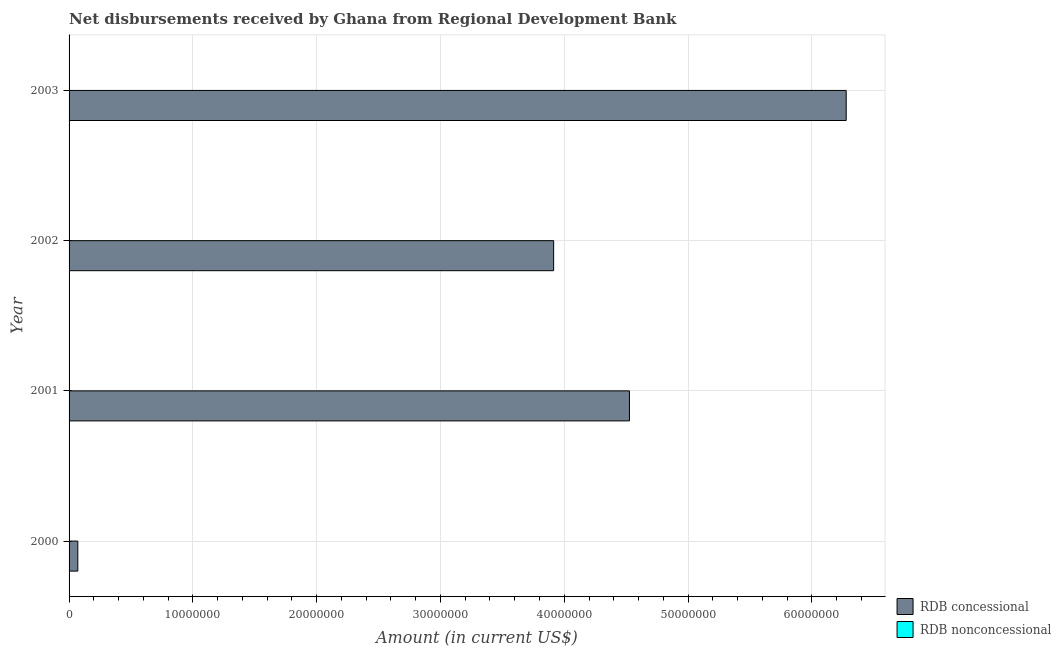How many different coloured bars are there?
Provide a succinct answer. 1. How many bars are there on the 1st tick from the bottom?
Provide a succinct answer. 1. What is the label of the 2nd group of bars from the top?
Your response must be concise. 2002. In how many cases, is the number of bars for a given year not equal to the number of legend labels?
Your answer should be very brief. 4. What is the net non concessional disbursements from rdb in 2003?
Your response must be concise. 0. Across all years, what is the maximum net concessional disbursements from rdb?
Your answer should be very brief. 6.28e+07. In which year was the net concessional disbursements from rdb maximum?
Ensure brevity in your answer.  2003. What is the total net concessional disbursements from rdb in the graph?
Give a very brief answer. 1.48e+08. What is the difference between the net concessional disbursements from rdb in 2000 and that in 2001?
Give a very brief answer. -4.46e+07. What is the difference between the net concessional disbursements from rdb in 2000 and the net non concessional disbursements from rdb in 2002?
Ensure brevity in your answer.  7.06e+05. What is the average net concessional disbursements from rdb per year?
Provide a short and direct response. 3.70e+07. What is the ratio of the net concessional disbursements from rdb in 2000 to that in 2003?
Your answer should be very brief. 0.01. Is the net concessional disbursements from rdb in 2001 less than that in 2002?
Make the answer very short. No. What is the difference between the highest and the second highest net concessional disbursements from rdb?
Provide a short and direct response. 1.75e+07. What is the difference between the highest and the lowest net concessional disbursements from rdb?
Your answer should be compact. 6.21e+07. In how many years, is the net non concessional disbursements from rdb greater than the average net non concessional disbursements from rdb taken over all years?
Make the answer very short. 0. How many bars are there?
Offer a very short reply. 4. How many years are there in the graph?
Give a very brief answer. 4. Does the graph contain grids?
Your answer should be very brief. Yes. Where does the legend appear in the graph?
Make the answer very short. Bottom right. How many legend labels are there?
Your answer should be very brief. 2. How are the legend labels stacked?
Your answer should be compact. Vertical. What is the title of the graph?
Your response must be concise. Net disbursements received by Ghana from Regional Development Bank. Does "Central government" appear as one of the legend labels in the graph?
Give a very brief answer. No. What is the label or title of the X-axis?
Keep it short and to the point. Amount (in current US$). What is the label or title of the Y-axis?
Your answer should be very brief. Year. What is the Amount (in current US$) of RDB concessional in 2000?
Give a very brief answer. 7.06e+05. What is the Amount (in current US$) in RDB nonconcessional in 2000?
Keep it short and to the point. 0. What is the Amount (in current US$) in RDB concessional in 2001?
Offer a very short reply. 4.53e+07. What is the Amount (in current US$) of RDB nonconcessional in 2001?
Your answer should be very brief. 0. What is the Amount (in current US$) of RDB concessional in 2002?
Your answer should be compact. 3.91e+07. What is the Amount (in current US$) of RDB nonconcessional in 2002?
Your answer should be very brief. 0. What is the Amount (in current US$) of RDB concessional in 2003?
Give a very brief answer. 6.28e+07. What is the Amount (in current US$) in RDB nonconcessional in 2003?
Provide a short and direct response. 0. Across all years, what is the maximum Amount (in current US$) in RDB concessional?
Give a very brief answer. 6.28e+07. Across all years, what is the minimum Amount (in current US$) in RDB concessional?
Offer a terse response. 7.06e+05. What is the total Amount (in current US$) in RDB concessional in the graph?
Make the answer very short. 1.48e+08. What is the total Amount (in current US$) in RDB nonconcessional in the graph?
Provide a short and direct response. 0. What is the difference between the Amount (in current US$) of RDB concessional in 2000 and that in 2001?
Your response must be concise. -4.46e+07. What is the difference between the Amount (in current US$) of RDB concessional in 2000 and that in 2002?
Offer a terse response. -3.84e+07. What is the difference between the Amount (in current US$) of RDB concessional in 2000 and that in 2003?
Your response must be concise. -6.21e+07. What is the difference between the Amount (in current US$) of RDB concessional in 2001 and that in 2002?
Make the answer very short. 6.12e+06. What is the difference between the Amount (in current US$) of RDB concessional in 2001 and that in 2003?
Your response must be concise. -1.75e+07. What is the difference between the Amount (in current US$) of RDB concessional in 2002 and that in 2003?
Provide a succinct answer. -2.36e+07. What is the average Amount (in current US$) of RDB concessional per year?
Your answer should be compact. 3.70e+07. What is the ratio of the Amount (in current US$) in RDB concessional in 2000 to that in 2001?
Give a very brief answer. 0.02. What is the ratio of the Amount (in current US$) of RDB concessional in 2000 to that in 2002?
Offer a terse response. 0.02. What is the ratio of the Amount (in current US$) of RDB concessional in 2000 to that in 2003?
Your answer should be very brief. 0.01. What is the ratio of the Amount (in current US$) of RDB concessional in 2001 to that in 2002?
Offer a terse response. 1.16. What is the ratio of the Amount (in current US$) in RDB concessional in 2001 to that in 2003?
Keep it short and to the point. 0.72. What is the ratio of the Amount (in current US$) in RDB concessional in 2002 to that in 2003?
Ensure brevity in your answer.  0.62. What is the difference between the highest and the second highest Amount (in current US$) of RDB concessional?
Keep it short and to the point. 1.75e+07. What is the difference between the highest and the lowest Amount (in current US$) of RDB concessional?
Ensure brevity in your answer.  6.21e+07. 